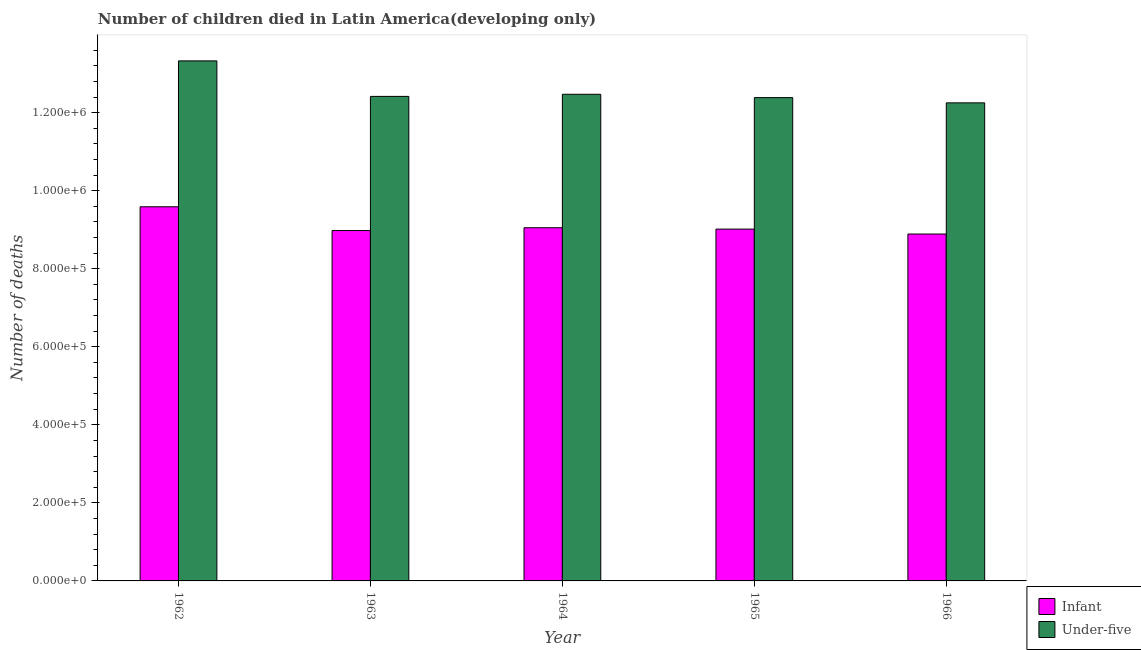Are the number of bars on each tick of the X-axis equal?
Offer a very short reply. Yes. What is the number of under-five deaths in 1965?
Keep it short and to the point. 1.24e+06. Across all years, what is the maximum number of under-five deaths?
Ensure brevity in your answer.  1.33e+06. Across all years, what is the minimum number of infant deaths?
Offer a very short reply. 8.89e+05. In which year was the number of under-five deaths minimum?
Provide a short and direct response. 1966. What is the total number of infant deaths in the graph?
Provide a succinct answer. 4.55e+06. What is the difference between the number of under-five deaths in 1963 and that in 1964?
Keep it short and to the point. -5453. What is the difference between the number of under-five deaths in 1963 and the number of infant deaths in 1965?
Make the answer very short. 3125. What is the average number of under-five deaths per year?
Offer a terse response. 1.26e+06. In the year 1965, what is the difference between the number of infant deaths and number of under-five deaths?
Your answer should be compact. 0. What is the ratio of the number of under-five deaths in 1964 to that in 1966?
Provide a succinct answer. 1.02. Is the number of infant deaths in 1962 less than that in 1963?
Ensure brevity in your answer.  No. Is the difference between the number of infant deaths in 1962 and 1964 greater than the difference between the number of under-five deaths in 1962 and 1964?
Provide a succinct answer. No. What is the difference between the highest and the second highest number of infant deaths?
Provide a short and direct response. 5.37e+04. What is the difference between the highest and the lowest number of infant deaths?
Provide a short and direct response. 6.98e+04. What does the 2nd bar from the left in 1962 represents?
Ensure brevity in your answer.  Under-five. What does the 1st bar from the right in 1963 represents?
Your response must be concise. Under-five. How many bars are there?
Provide a short and direct response. 10. Does the graph contain any zero values?
Give a very brief answer. No. How are the legend labels stacked?
Your response must be concise. Vertical. What is the title of the graph?
Offer a terse response. Number of children died in Latin America(developing only). Does "Commercial service imports" appear as one of the legend labels in the graph?
Offer a very short reply. No. What is the label or title of the X-axis?
Your answer should be compact. Year. What is the label or title of the Y-axis?
Ensure brevity in your answer.  Number of deaths. What is the Number of deaths of Infant in 1962?
Ensure brevity in your answer.  9.59e+05. What is the Number of deaths of Under-five in 1962?
Offer a terse response. 1.33e+06. What is the Number of deaths of Infant in 1963?
Make the answer very short. 8.98e+05. What is the Number of deaths in Under-five in 1963?
Provide a short and direct response. 1.24e+06. What is the Number of deaths of Infant in 1964?
Offer a terse response. 9.05e+05. What is the Number of deaths of Under-five in 1964?
Offer a terse response. 1.25e+06. What is the Number of deaths of Infant in 1965?
Keep it short and to the point. 9.02e+05. What is the Number of deaths in Under-five in 1965?
Your answer should be compact. 1.24e+06. What is the Number of deaths in Infant in 1966?
Your answer should be very brief. 8.89e+05. What is the Number of deaths of Under-five in 1966?
Your answer should be very brief. 1.23e+06. Across all years, what is the maximum Number of deaths of Infant?
Your answer should be very brief. 9.59e+05. Across all years, what is the maximum Number of deaths of Under-five?
Your answer should be very brief. 1.33e+06. Across all years, what is the minimum Number of deaths of Infant?
Keep it short and to the point. 8.89e+05. Across all years, what is the minimum Number of deaths of Under-five?
Offer a very short reply. 1.23e+06. What is the total Number of deaths of Infant in the graph?
Offer a terse response. 4.55e+06. What is the total Number of deaths of Under-five in the graph?
Provide a short and direct response. 6.28e+06. What is the difference between the Number of deaths of Infant in 1962 and that in 1963?
Offer a very short reply. 6.10e+04. What is the difference between the Number of deaths in Under-five in 1962 and that in 1963?
Offer a very short reply. 9.10e+04. What is the difference between the Number of deaths of Infant in 1962 and that in 1964?
Your answer should be very brief. 5.37e+04. What is the difference between the Number of deaths in Under-five in 1962 and that in 1964?
Provide a short and direct response. 8.56e+04. What is the difference between the Number of deaths of Infant in 1962 and that in 1965?
Your response must be concise. 5.72e+04. What is the difference between the Number of deaths in Under-five in 1962 and that in 1965?
Offer a terse response. 9.41e+04. What is the difference between the Number of deaths in Infant in 1962 and that in 1966?
Offer a terse response. 6.98e+04. What is the difference between the Number of deaths of Under-five in 1962 and that in 1966?
Ensure brevity in your answer.  1.08e+05. What is the difference between the Number of deaths of Infant in 1963 and that in 1964?
Provide a succinct answer. -7280. What is the difference between the Number of deaths in Under-five in 1963 and that in 1964?
Give a very brief answer. -5453. What is the difference between the Number of deaths of Infant in 1963 and that in 1965?
Your answer should be very brief. -3725. What is the difference between the Number of deaths in Under-five in 1963 and that in 1965?
Your answer should be compact. 3125. What is the difference between the Number of deaths of Infant in 1963 and that in 1966?
Your answer should be compact. 8853. What is the difference between the Number of deaths of Under-five in 1963 and that in 1966?
Your answer should be compact. 1.65e+04. What is the difference between the Number of deaths in Infant in 1964 and that in 1965?
Offer a terse response. 3555. What is the difference between the Number of deaths of Under-five in 1964 and that in 1965?
Offer a terse response. 8578. What is the difference between the Number of deaths of Infant in 1964 and that in 1966?
Provide a short and direct response. 1.61e+04. What is the difference between the Number of deaths of Under-five in 1964 and that in 1966?
Ensure brevity in your answer.  2.20e+04. What is the difference between the Number of deaths in Infant in 1965 and that in 1966?
Give a very brief answer. 1.26e+04. What is the difference between the Number of deaths in Under-five in 1965 and that in 1966?
Offer a very short reply. 1.34e+04. What is the difference between the Number of deaths of Infant in 1962 and the Number of deaths of Under-five in 1963?
Your answer should be compact. -2.83e+05. What is the difference between the Number of deaths in Infant in 1962 and the Number of deaths in Under-five in 1964?
Your answer should be compact. -2.88e+05. What is the difference between the Number of deaths in Infant in 1962 and the Number of deaths in Under-five in 1965?
Offer a terse response. -2.80e+05. What is the difference between the Number of deaths of Infant in 1962 and the Number of deaths of Under-five in 1966?
Your answer should be compact. -2.66e+05. What is the difference between the Number of deaths in Infant in 1963 and the Number of deaths in Under-five in 1964?
Provide a succinct answer. -3.49e+05. What is the difference between the Number of deaths of Infant in 1963 and the Number of deaths of Under-five in 1965?
Provide a succinct answer. -3.41e+05. What is the difference between the Number of deaths in Infant in 1963 and the Number of deaths in Under-five in 1966?
Offer a very short reply. -3.27e+05. What is the difference between the Number of deaths in Infant in 1964 and the Number of deaths in Under-five in 1965?
Make the answer very short. -3.33e+05. What is the difference between the Number of deaths of Infant in 1964 and the Number of deaths of Under-five in 1966?
Your response must be concise. -3.20e+05. What is the difference between the Number of deaths in Infant in 1965 and the Number of deaths in Under-five in 1966?
Your answer should be compact. -3.24e+05. What is the average Number of deaths of Infant per year?
Your answer should be compact. 9.10e+05. What is the average Number of deaths in Under-five per year?
Your answer should be compact. 1.26e+06. In the year 1962, what is the difference between the Number of deaths of Infant and Number of deaths of Under-five?
Your answer should be very brief. -3.74e+05. In the year 1963, what is the difference between the Number of deaths in Infant and Number of deaths in Under-five?
Your answer should be very brief. -3.44e+05. In the year 1964, what is the difference between the Number of deaths in Infant and Number of deaths in Under-five?
Give a very brief answer. -3.42e+05. In the year 1965, what is the difference between the Number of deaths in Infant and Number of deaths in Under-five?
Provide a succinct answer. -3.37e+05. In the year 1966, what is the difference between the Number of deaths in Infant and Number of deaths in Under-five?
Offer a terse response. -3.36e+05. What is the ratio of the Number of deaths in Infant in 1962 to that in 1963?
Make the answer very short. 1.07. What is the ratio of the Number of deaths in Under-five in 1962 to that in 1963?
Ensure brevity in your answer.  1.07. What is the ratio of the Number of deaths in Infant in 1962 to that in 1964?
Give a very brief answer. 1.06. What is the ratio of the Number of deaths of Under-five in 1962 to that in 1964?
Give a very brief answer. 1.07. What is the ratio of the Number of deaths of Infant in 1962 to that in 1965?
Offer a very short reply. 1.06. What is the ratio of the Number of deaths of Under-five in 1962 to that in 1965?
Provide a succinct answer. 1.08. What is the ratio of the Number of deaths of Infant in 1962 to that in 1966?
Make the answer very short. 1.08. What is the ratio of the Number of deaths in Under-five in 1962 to that in 1966?
Make the answer very short. 1.09. What is the ratio of the Number of deaths of Infant in 1963 to that in 1964?
Your answer should be very brief. 0.99. What is the ratio of the Number of deaths of Under-five in 1963 to that in 1964?
Make the answer very short. 1. What is the ratio of the Number of deaths in Infant in 1963 to that in 1965?
Ensure brevity in your answer.  1. What is the ratio of the Number of deaths in Under-five in 1963 to that in 1966?
Offer a terse response. 1.01. What is the ratio of the Number of deaths in Infant in 1964 to that in 1965?
Your answer should be compact. 1. What is the ratio of the Number of deaths in Infant in 1964 to that in 1966?
Provide a succinct answer. 1.02. What is the ratio of the Number of deaths in Under-five in 1964 to that in 1966?
Offer a very short reply. 1.02. What is the ratio of the Number of deaths in Infant in 1965 to that in 1966?
Keep it short and to the point. 1.01. What is the ratio of the Number of deaths of Under-five in 1965 to that in 1966?
Offer a very short reply. 1.01. What is the difference between the highest and the second highest Number of deaths of Infant?
Keep it short and to the point. 5.37e+04. What is the difference between the highest and the second highest Number of deaths of Under-five?
Your response must be concise. 8.56e+04. What is the difference between the highest and the lowest Number of deaths of Infant?
Give a very brief answer. 6.98e+04. What is the difference between the highest and the lowest Number of deaths in Under-five?
Make the answer very short. 1.08e+05. 